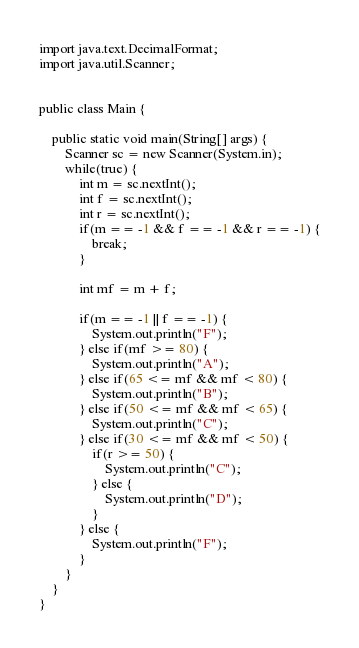<code> <loc_0><loc_0><loc_500><loc_500><_Java_>import java.text.DecimalFormat;
import java.util.Scanner;


public class Main {
	
	public static void main(String[] args) {
		Scanner sc = new Scanner(System.in);
		while(true) {
			int m = sc.nextInt();
			int f = sc.nextInt();
			int r = sc.nextInt();
			if(m == -1 && f == -1 && r == -1) {
				break;
			}
			
			int mf = m + f;
			
			if(m == -1 || f == -1) {
				System.out.println("F");
			} else if(mf >= 80) {
				System.out.println("A");
			} else if(65 <= mf && mf < 80) {
				System.out.println("B");
			} else if(50 <= mf && mf < 65) {
				System.out.println("C");
			} else if(30 <= mf && mf < 50) {
				if(r >= 50) {
					System.out.println("C");
				} else {
					System.out.println("D");
				}
			} else {
				System.out.println("F");
			}
		}
	}
}</code> 